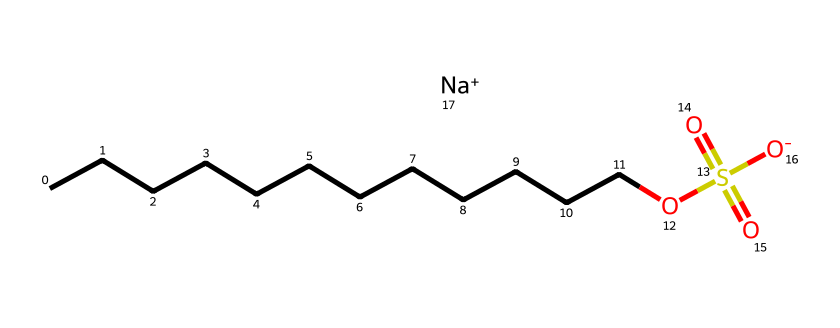What is the molecular formula of sodium lauryl sulfate? The SMILES representation indicates the presence of 12 carbon atoms (C) from the long hydrocarbon tail, 1 sulfur atom (S), 4 oxygen atoms (O), and 1 sodium atom (Na). Therefore, the molecular formula is C12H25NaO4S.
Answer: C12H25NaO4S How many oxygen atoms does sodium lauryl sulfate contain? The SMILES representation shows the presence of four oxygen atoms in sodium lauryl sulfate as denoted by the "O" symbols.
Answer: 4 What type of functional group is present in sodium lauryl sulfate? In the SMILES representation, the presence of “OS(=O)(=O)” indicates a sulfate functional group, which is characteristic of surfactants like sodium lauryl sulfate.
Answer: sulfate What is the significance of the hydrophobic tail in sodium lauryl sulfate? The long hydrocarbon chain (12 carbon atoms) provides hydrophobic characteristics, allowing the molecule to interact with oils and grease, which is essential for its function as a surfactant.
Answer: hydrophobic How does sodium lauryl sulfate potentially impact skin barrier function? Sodium lauryl sulfate can disrupt the lipid bilayers in the skin barrier, leading to increased permeability and irritation, impacting overall skin health.
Answer: disrupts barrier What cation is associated with sodium lauryl sulfate in the chemical structure? The SMILES representation includes "[Na+]", indicating that sodium is the cation associated with this surfactant.
Answer: sodium How many carbon atoms are present in the non-polar tail of sodium lauryl sulfate? Analyzing the "CCCCCCCCCCCC" portion of the SMILES structure shows that there are a total of 12 carbon atoms in the non-polar tail.
Answer: 12 